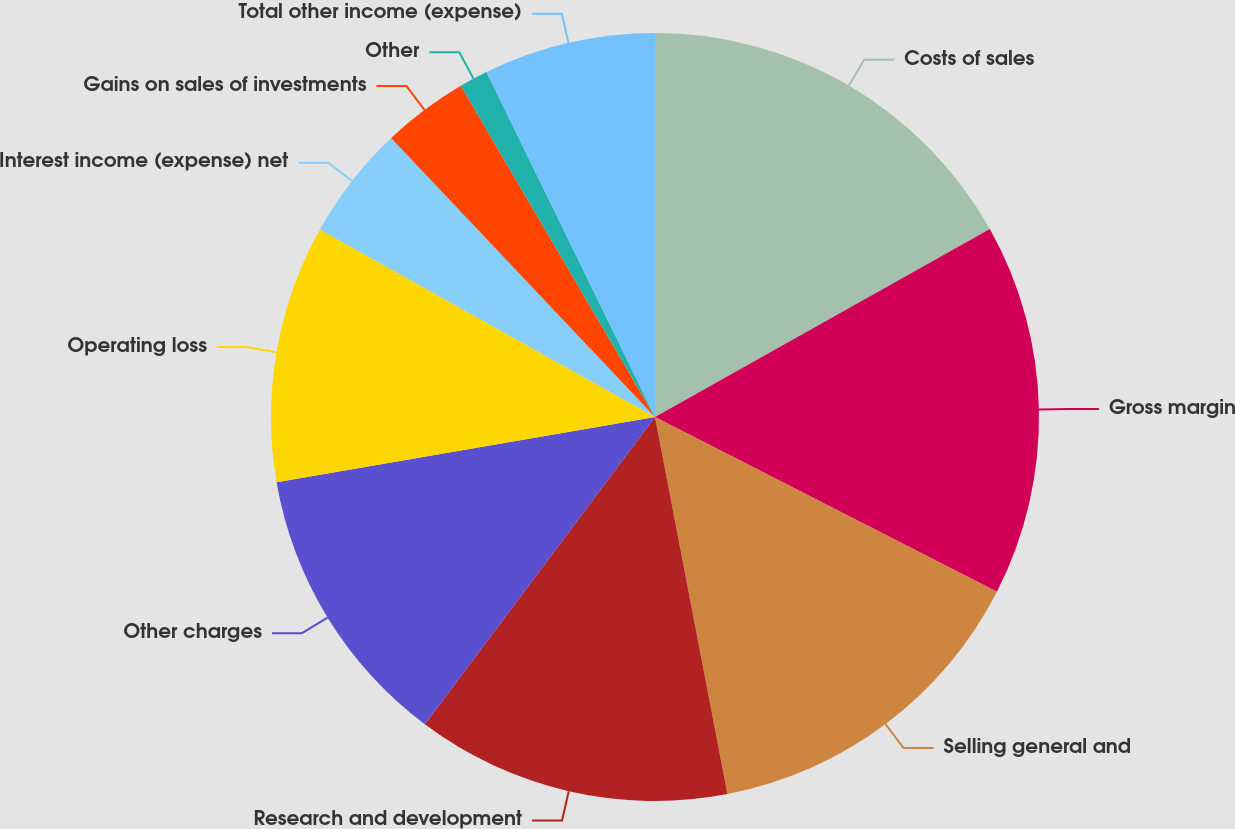Convert chart. <chart><loc_0><loc_0><loc_500><loc_500><pie_chart><fcel>Costs of sales<fcel>Gross margin<fcel>Selling general and<fcel>Research and development<fcel>Other charges<fcel>Operating loss<fcel>Interest income (expense) net<fcel>Gains on sales of investments<fcel>Other<fcel>Total other income (expense)<nl><fcel>16.86%<fcel>15.66%<fcel>14.46%<fcel>13.25%<fcel>12.05%<fcel>10.84%<fcel>4.82%<fcel>3.62%<fcel>1.21%<fcel>7.23%<nl></chart> 